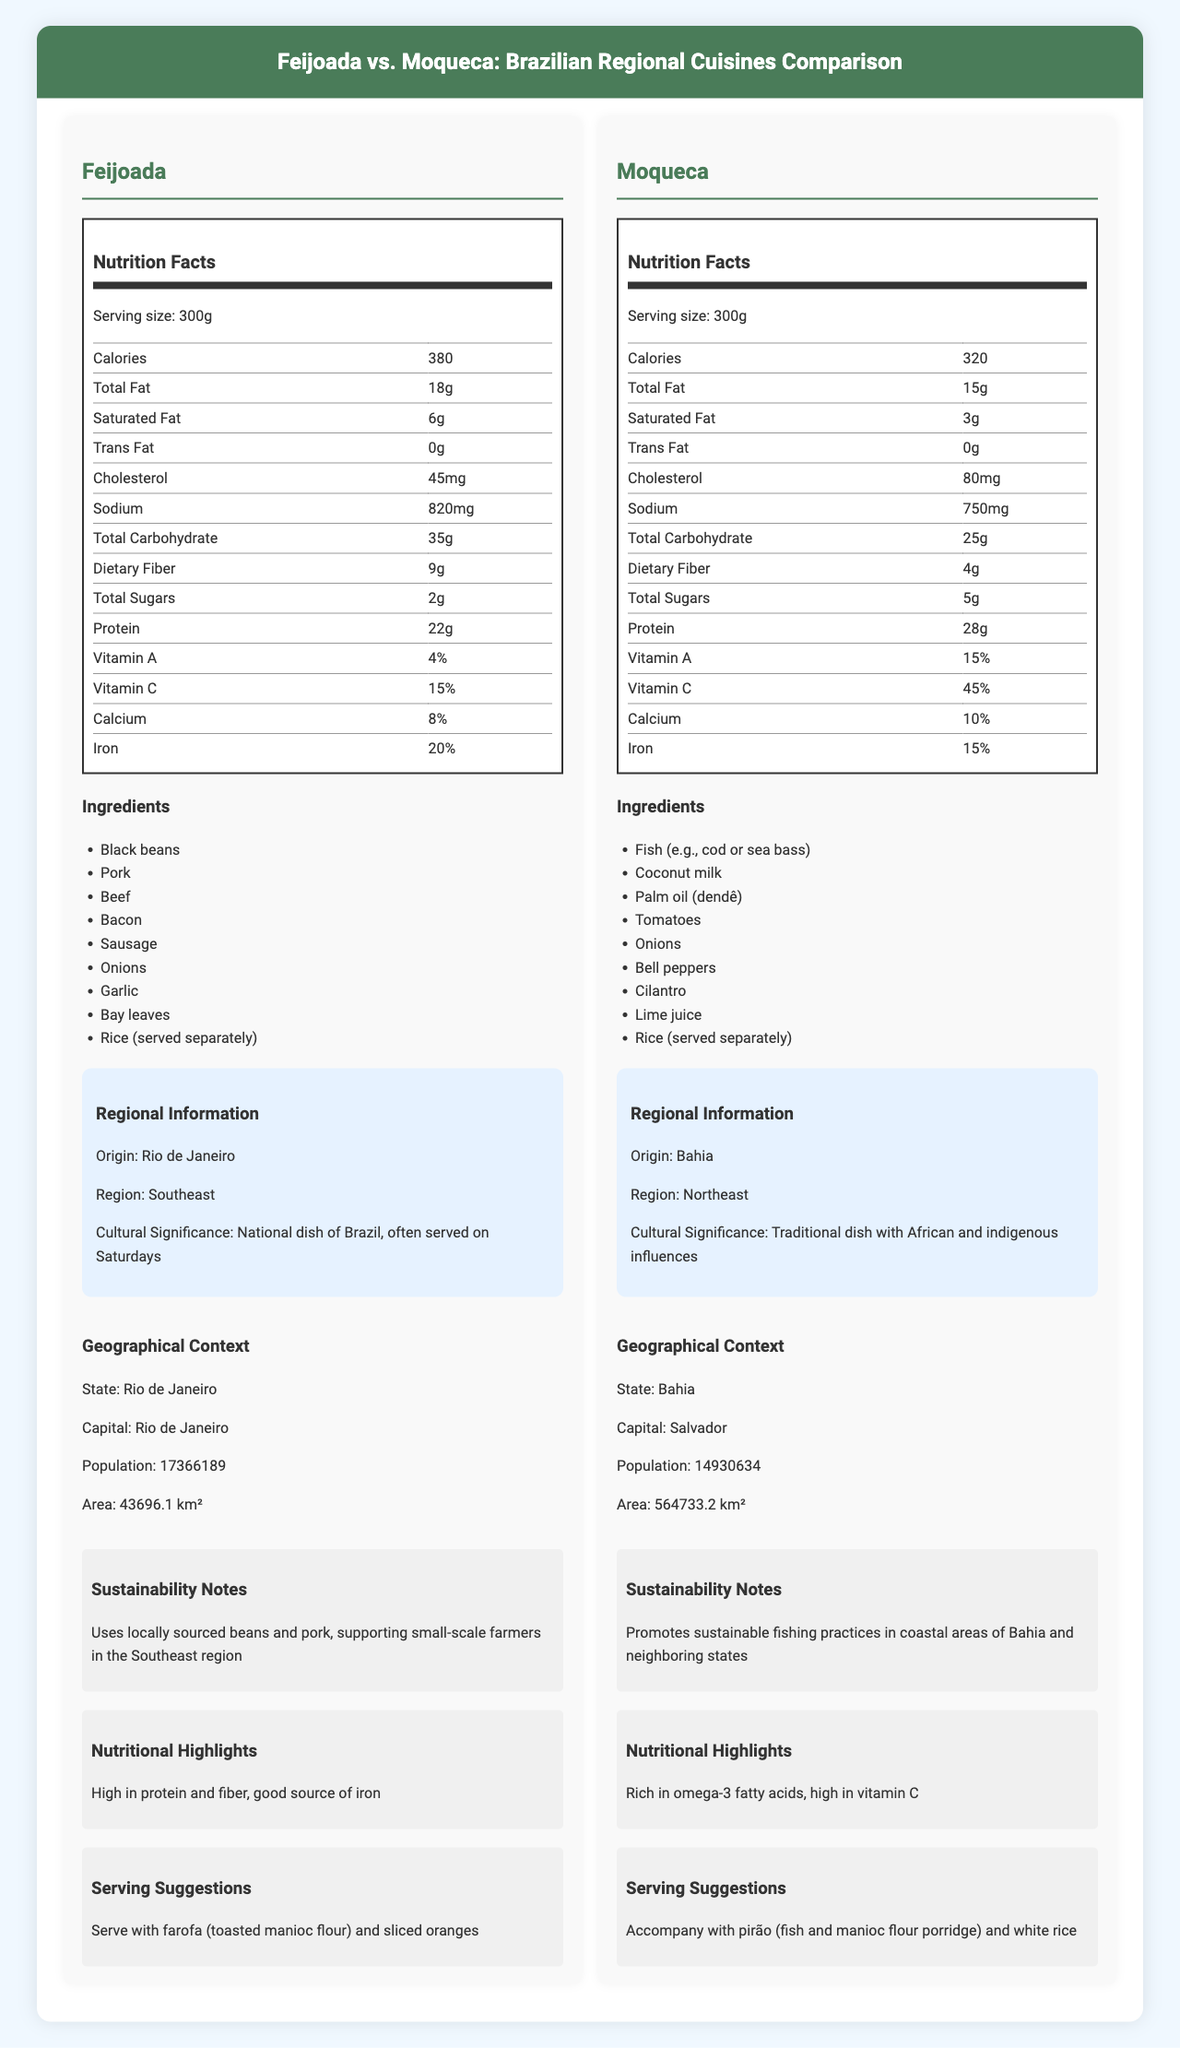what is the origin of Feijoada? According to the regional information section, Feijoada originates from Rio de Janeiro.
Answer: Rio de Janeiro which dish has higher protein content? The nutrition facts show that Feijoada has 22g of protein while Moqueca has 28g of protein.
Answer: Moqueca what are the main ingredients of Moqueca? The ingredients section lists these items under Moqueca.
Answer: Fish, Coconut milk, Palm oil, Tomatoes, Onions, Bell peppers, Cilantro, Lime juice, Rice how many grams of saturated fat does Feijoada contain? The nutrition facts for Feijoada indicate it contains 6g of saturated fat.
Answer: 6g which dish has higher vitamin C content? Feijoada has 15% vitamin C, whereas Moqueca has 45% vitamin C.
Answer: Moqueca which dish is traditionally served with farofa and sliced oranges? A. Feijoada B. Moqueca C. Both The serving suggestions indicate that Feijoada is served with farofa and sliced oranges.
Answer: A which cuisine is richer in omega-3 fatty acids? A. Feijoada B. Moqueca C. Both The nutritional highlights state that Moqueca is rich in omega-3 fatty acids.
Answer: B does feijoada have more calories than moqueca? Feijoada has 380 calories, while Moqueca has 320 calories.
Answer: Yes summarize the document content. The document offers a comprehensive overview of Feijoada and Moqueca, comparing their nutritional values, ingredients, origins, cultural impact, and serving suggestions.
Answer: The document is a detailed comparison of two Brazilian regional cuisines: Feijoada and Moqueca. It includes information on their nutritional facts, ingredients, regional and cultural significance, geographical context, sustainability, and serving suggestions. Additionally, it highlights the unique nutritional benefits of each dish. which dish has higher dietary fiber content? The nutrition facts table notes that Feijoada contains 9g of dietary fiber, whereas Moqueca contains only 4g.
Answer: Feijoada what is the cultural significance of Moqueca? The regional information section explains that Moqueca is a traditional dish with influences from African and indigenous cultures.
Answer: Traditional dish with African and indigenous influences which state has a larger area, Rio de Janeiro or Bahia? The geographical context states that Rio de Janeiro's area is 43,696.1 km² whereas Bahia's area is 564,733.2 km².
Answer: Bahia which dish promotes sustainable fishing practices? The sustainability notes mention that Moqueca promotes sustainable fishing practices in coastal areas of Bahia and neighboring states.
Answer: Moqueca what is the calcium content in Feijoada? The nutrition facts for Feijoada show it contains 8% calcium.
Answer: 8% how many meals can you get per container if the serving size is 300g? According to the serving information, there is one serving per container.
Answer: 1 which region has a greater population: the area where Feijoada or Moqueca originates? The geographical context states Rio de Janeiro has a population of 17,366,189, which is more than Bahia's population of 14,930,634.
Answer: Rio de Janeiro what is the serving suggestion for Moqueca? The serving suggestions section notes that Moqueca should be served with pirão and white rice.
Answer: Accompany with pirão (fish and manioc flour porridge) and white rice Feijoada uses local ingredients from the Bahia region. True or False? The sustainability notes reveal that Feijoada uses locally sourced beans and pork from the Southeast region (Rio de Janeiro), not Bahia.
Answer: False what is the history behind Feijoada's ingredients? The document does not provide specific historical details about the development or history behind Feijoada's ingredients.
Answer: Not enough information 